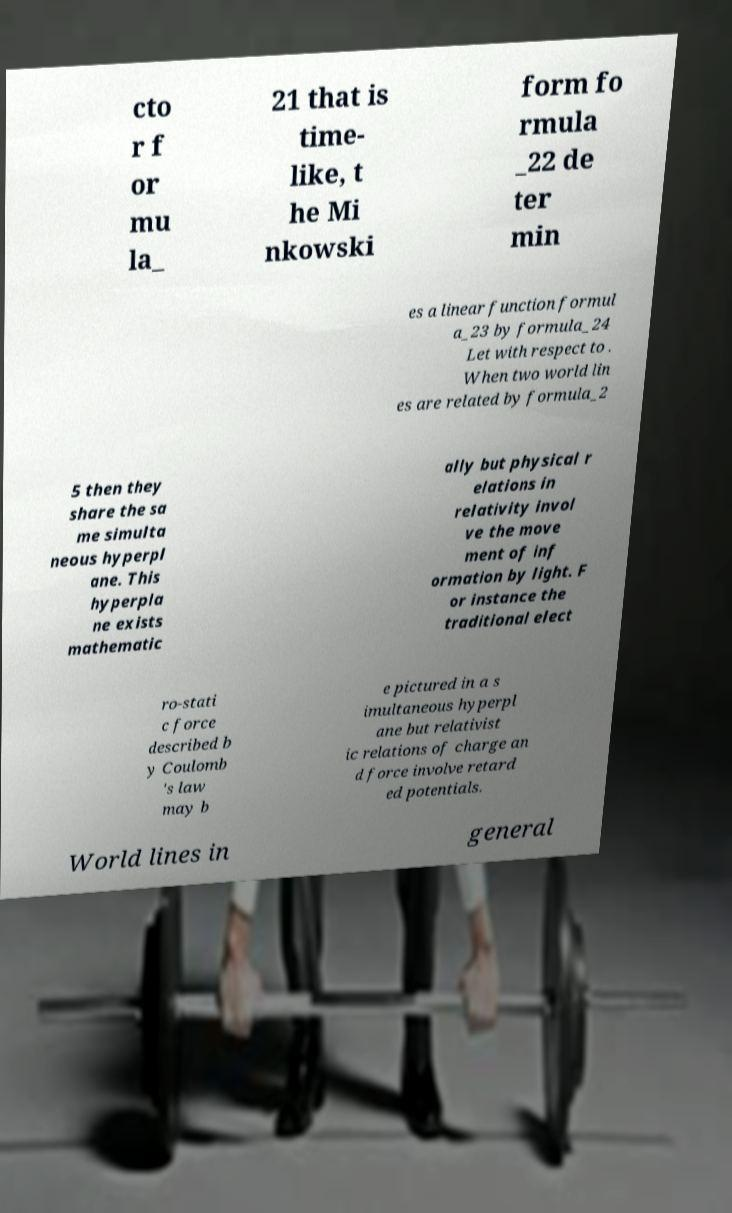There's text embedded in this image that I need extracted. Can you transcribe it verbatim? cto r f or mu la_ 21 that is time- like, t he Mi nkowski form fo rmula _22 de ter min es a linear function formul a_23 by formula_24 Let with respect to . When two world lin es are related by formula_2 5 then they share the sa me simulta neous hyperpl ane. This hyperpla ne exists mathematic ally but physical r elations in relativity invol ve the move ment of inf ormation by light. F or instance the traditional elect ro-stati c force described b y Coulomb 's law may b e pictured in a s imultaneous hyperpl ane but relativist ic relations of charge an d force involve retard ed potentials. World lines in general 